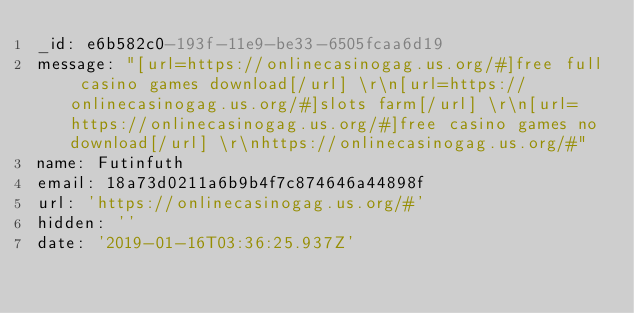<code> <loc_0><loc_0><loc_500><loc_500><_YAML_>_id: e6b582c0-193f-11e9-be33-6505fcaa6d19
message: "[url=https://onlinecasinogag.us.org/#]free full casino games download[/url] \r\n[url=https://onlinecasinogag.us.org/#]slots farm[/url] \r\n[url=https://onlinecasinogag.us.org/#]free casino games no download[/url] \r\nhttps://onlinecasinogag.us.org/#"
name: Futinfuth
email: 18a73d0211a6b9b4f7c874646a44898f
url: 'https://onlinecasinogag.us.org/#'
hidden: ''
date: '2019-01-16T03:36:25.937Z'
</code> 